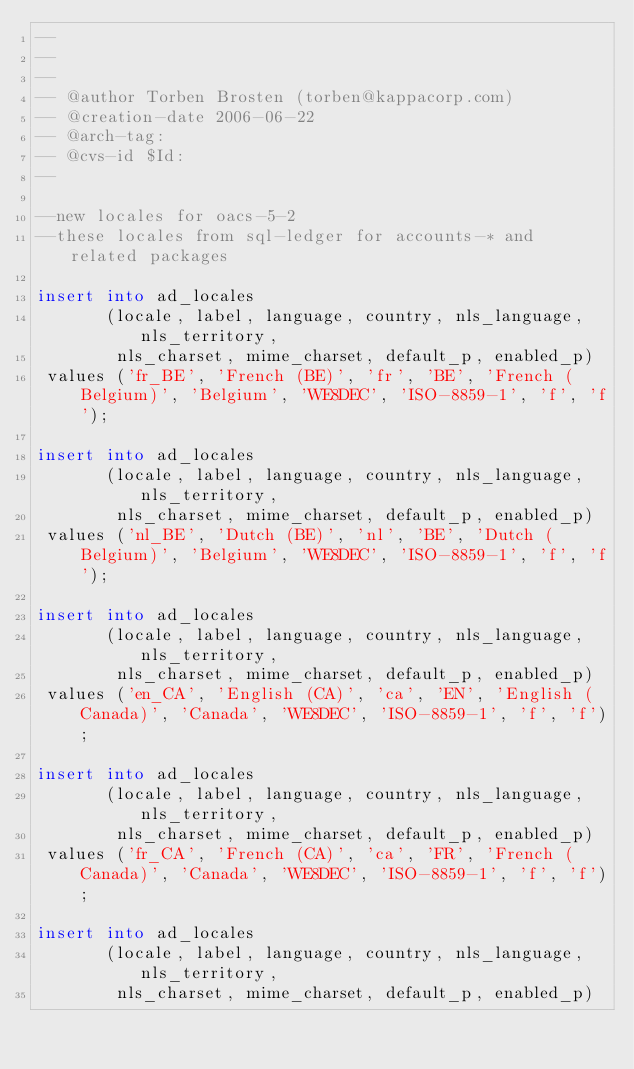Convert code to text. <code><loc_0><loc_0><loc_500><loc_500><_SQL_>-- 
-- 
-- 
-- @author Torben Brosten (torben@kappacorp.com)
-- @creation-date 2006-06-22
-- @arch-tag: 
-- @cvs-id $Id:
--

--new locales for oacs-5-2
--these locales from sql-ledger for accounts-* and related packages

insert into ad_locales
       (locale, label, language, country, nls_language, nls_territory,
        nls_charset, mime_charset, default_p, enabled_p)
 values ('fr_BE', 'French (BE)', 'fr', 'BE', 'French (Belgium)', 'Belgium', 'WE8DEC', 'ISO-8859-1', 'f', 'f');

insert into ad_locales
       (locale, label, language, country, nls_language, nls_territory,
        nls_charset, mime_charset, default_p, enabled_p)
 values ('nl_BE', 'Dutch (BE)', 'nl', 'BE', 'Dutch (Belgium)', 'Belgium', 'WE8DEC', 'ISO-8859-1', 'f', 'f');

insert into ad_locales
       (locale, label, language, country, nls_language, nls_territory,
        nls_charset, mime_charset, default_p, enabled_p)
 values ('en_CA', 'English (CA)', 'ca', 'EN', 'English (Canada)', 'Canada', 'WE8DEC', 'ISO-8859-1', 'f', 'f');

insert into ad_locales
       (locale, label, language, country, nls_language, nls_territory,
        nls_charset, mime_charset, default_p, enabled_p)
 values ('fr_CA', 'French (CA)', 'ca', 'FR', 'French (Canada)', 'Canada', 'WE8DEC', 'ISO-8859-1', 'f', 'f');

insert into ad_locales
       (locale, label, language, country, nls_language, nls_territory,
        nls_charset, mime_charset, default_p, enabled_p)</code> 